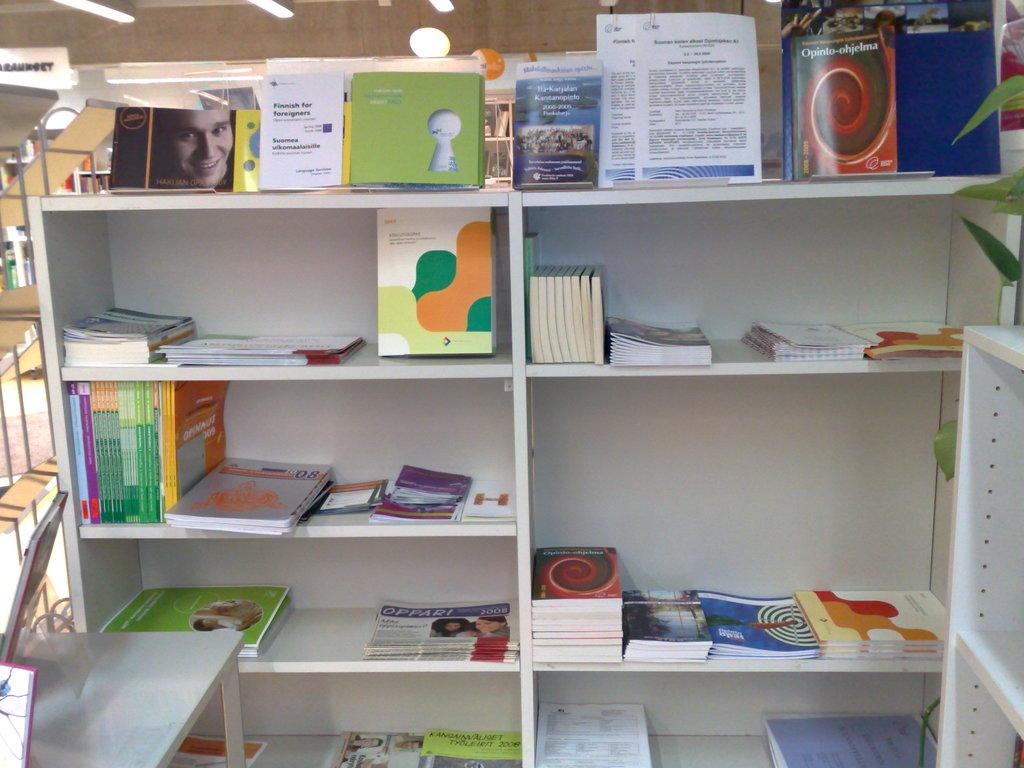What can be seen on the shelves in the image? There are books on the shelves in the image. What can be seen illuminating the area in the image? There are lights visible in the image. What type of paper is present in the image? There are white color papers in the image. What is written on the papers in the image? Something is written on the papers in the image. Can you see a rake being used to write on the papers in the image? There is no rake present in the image, and it is not being used to write on the papers. Is there a boat visible in the image? There is no boat present in the image. 